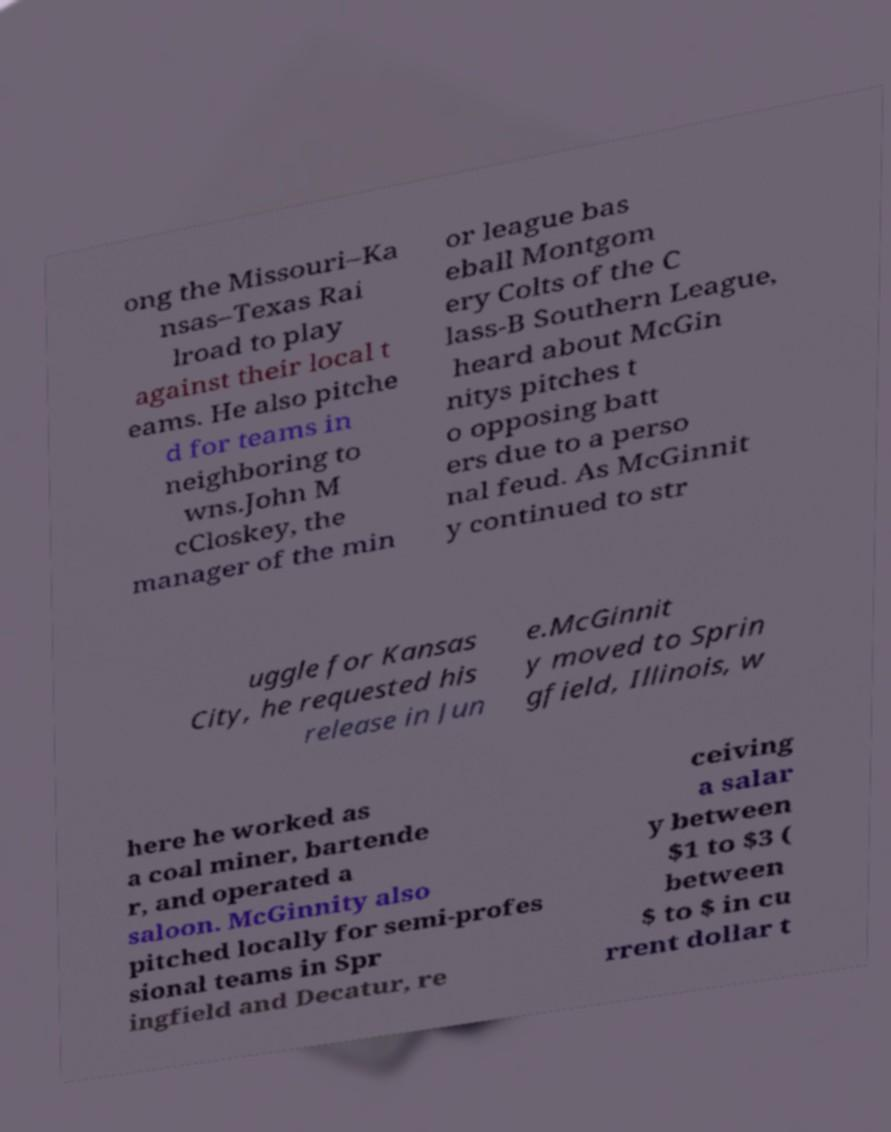Can you accurately transcribe the text from the provided image for me? ong the Missouri–Ka nsas–Texas Rai lroad to play against their local t eams. He also pitche d for teams in neighboring to wns.John M cCloskey, the manager of the min or league bas eball Montgom ery Colts of the C lass-B Southern League, heard about McGin nitys pitches t o opposing batt ers due to a perso nal feud. As McGinnit y continued to str uggle for Kansas City, he requested his release in Jun e.McGinnit y moved to Sprin gfield, Illinois, w here he worked as a coal miner, bartende r, and operated a saloon. McGinnity also pitched locally for semi-profes sional teams in Spr ingfield and Decatur, re ceiving a salar y between $1 to $3 ( between $ to $ in cu rrent dollar t 